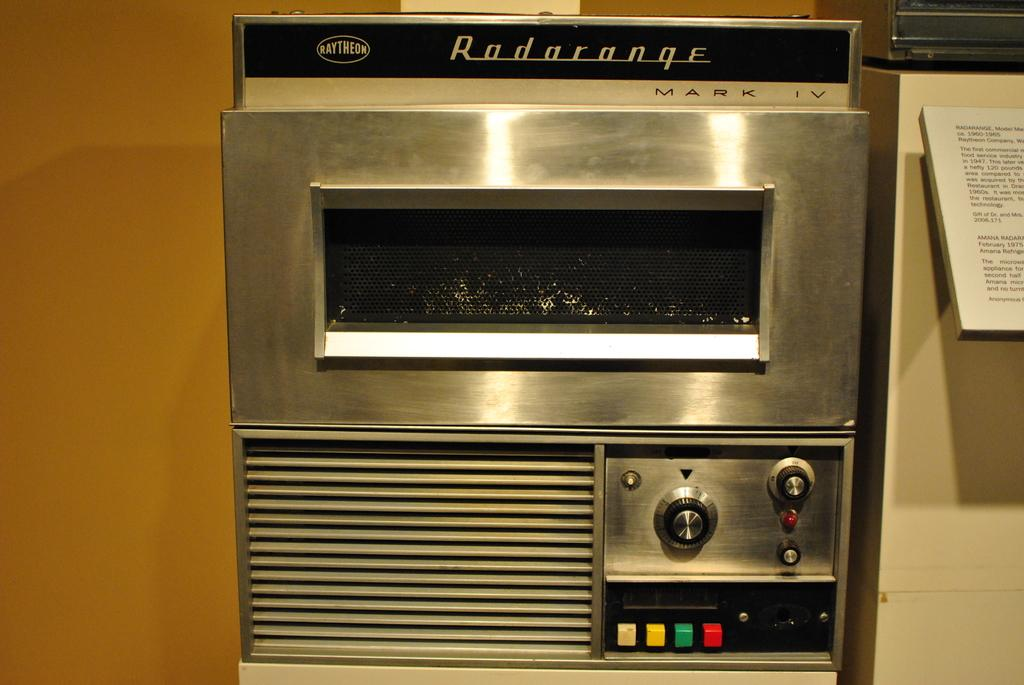<image>
Offer a succinct explanation of the picture presented. Silver oven named Radarange that has many buttons. 